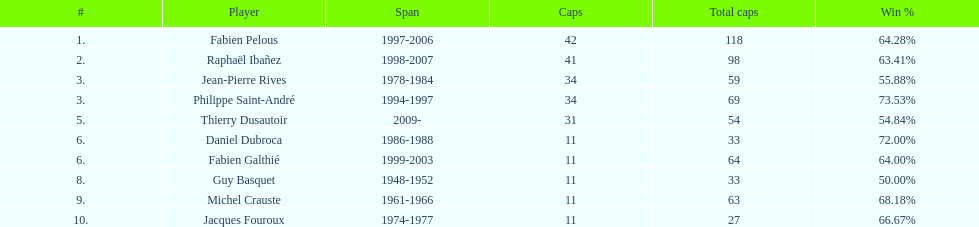Who possessed the highest winning percentage? Philippe Saint-André. 